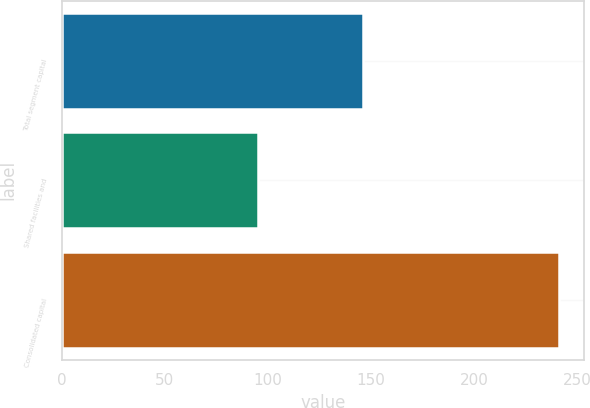Convert chart. <chart><loc_0><loc_0><loc_500><loc_500><bar_chart><fcel>Total segment capital<fcel>Shared facilities and<fcel>Consolidated capital<nl><fcel>146<fcel>95<fcel>241<nl></chart> 